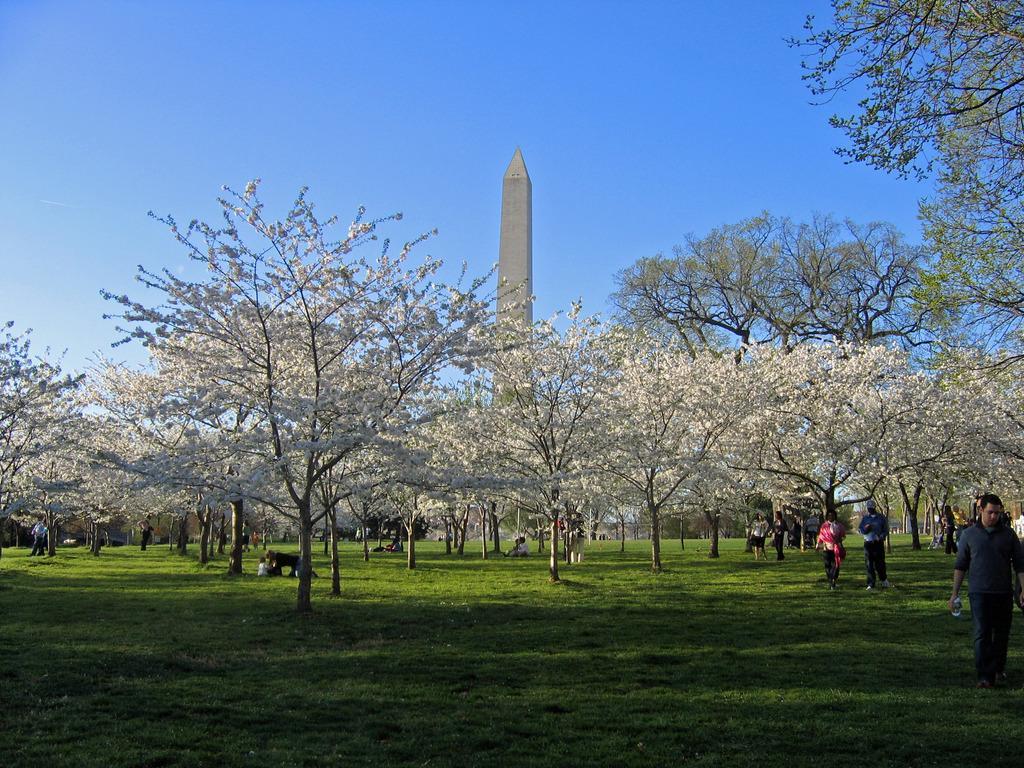In one or two sentences, can you explain what this image depicts? In the picture I can see some people are on the grass, there we can see some trees, building. 